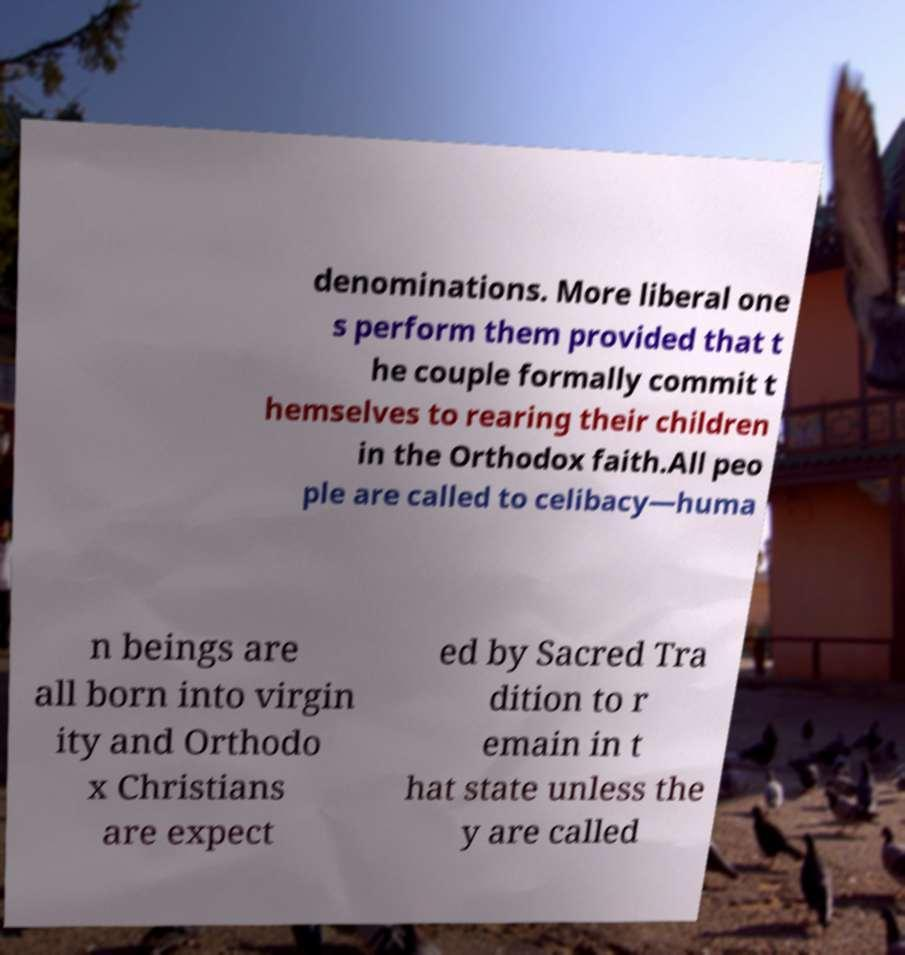Please identify and transcribe the text found in this image. denominations. More liberal one s perform them provided that t he couple formally commit t hemselves to rearing their children in the Orthodox faith.All peo ple are called to celibacy—huma n beings are all born into virgin ity and Orthodo x Christians are expect ed by Sacred Tra dition to r emain in t hat state unless the y are called 